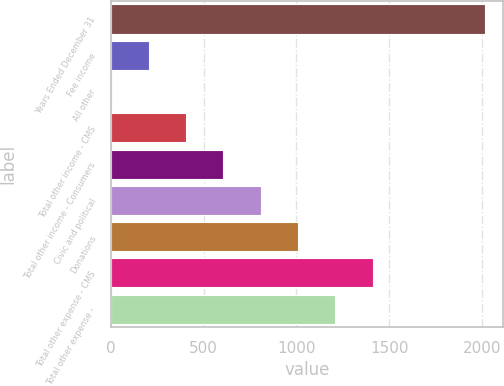Convert chart. <chart><loc_0><loc_0><loc_500><loc_500><bar_chart><fcel>Years Ended December 31<fcel>Fee income<fcel>All other<fcel>Total other income - CMS<fcel>Total other income - Consumers<fcel>Civic and political<fcel>Donations<fcel>Total other expense - CMS<fcel>Total other expense -<nl><fcel>2016<fcel>203.4<fcel>2<fcel>404.8<fcel>606.2<fcel>807.6<fcel>1009<fcel>1411.8<fcel>1210.4<nl></chart> 